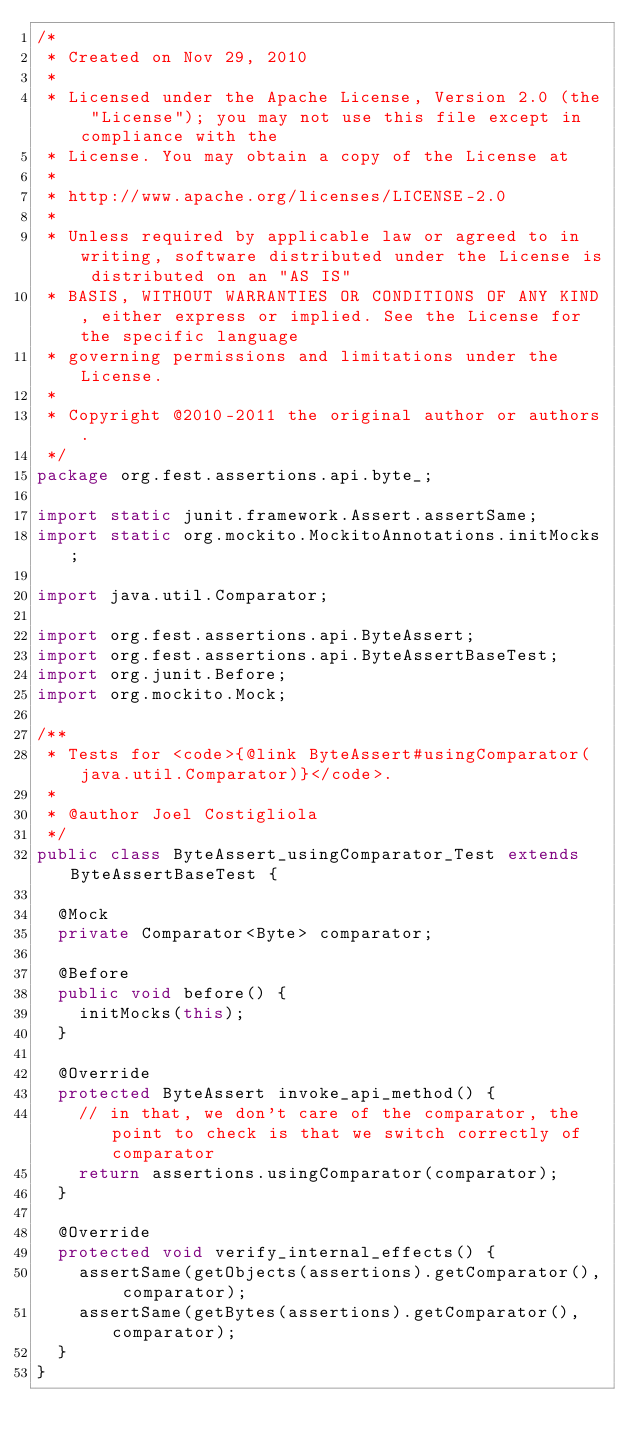Convert code to text. <code><loc_0><loc_0><loc_500><loc_500><_Java_>/*
 * Created on Nov 29, 2010
 * 
 * Licensed under the Apache License, Version 2.0 (the "License"); you may not use this file except in compliance with the
 * License. You may obtain a copy of the License at
 * 
 * http://www.apache.org/licenses/LICENSE-2.0
 * 
 * Unless required by applicable law or agreed to in writing, software distributed under the License is distributed on an "AS IS"
 * BASIS, WITHOUT WARRANTIES OR CONDITIONS OF ANY KIND, either express or implied. See the License for the specific language
 * governing permissions and limitations under the License.
 * 
 * Copyright @2010-2011 the original author or authors.
 */
package org.fest.assertions.api.byte_;

import static junit.framework.Assert.assertSame;
import static org.mockito.MockitoAnnotations.initMocks;

import java.util.Comparator;

import org.fest.assertions.api.ByteAssert;
import org.fest.assertions.api.ByteAssertBaseTest;
import org.junit.Before;
import org.mockito.Mock;

/**
 * Tests for <code>{@link ByteAssert#usingComparator(java.util.Comparator)}</code>.
 * 
 * @author Joel Costigliola
 */
public class ByteAssert_usingComparator_Test extends ByteAssertBaseTest {

  @Mock
  private Comparator<Byte> comparator;

  @Before
  public void before() {
    initMocks(this);
  }

  @Override
  protected ByteAssert invoke_api_method() {
    // in that, we don't care of the comparator, the point to check is that we switch correctly of comparator
    return assertions.usingComparator(comparator);
  }

  @Override
  protected void verify_internal_effects() {
    assertSame(getObjects(assertions).getComparator(), comparator);
    assertSame(getBytes(assertions).getComparator(), comparator);
  }
}
</code> 